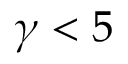<formula> <loc_0><loc_0><loc_500><loc_500>\gamma < 5</formula> 